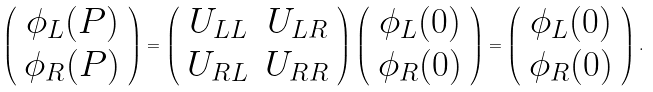Convert formula to latex. <formula><loc_0><loc_0><loc_500><loc_500>\left ( \begin{array} { c } \phi _ { L } ( P ) \\ \phi _ { R } ( P ) \end{array} \right ) = \left ( \begin{array} { c c } U _ { L L } & U _ { L R } \\ U _ { R L } & U _ { R R } \\ \end{array} \right ) \left ( \begin{array} { c } \phi _ { L } ( 0 ) \\ \phi _ { R } ( 0 ) \end{array} \right ) = \left ( \begin{array} { c } \phi _ { L } ( 0 ) \\ \phi _ { R } ( 0 ) \end{array} \right ) .</formula> 